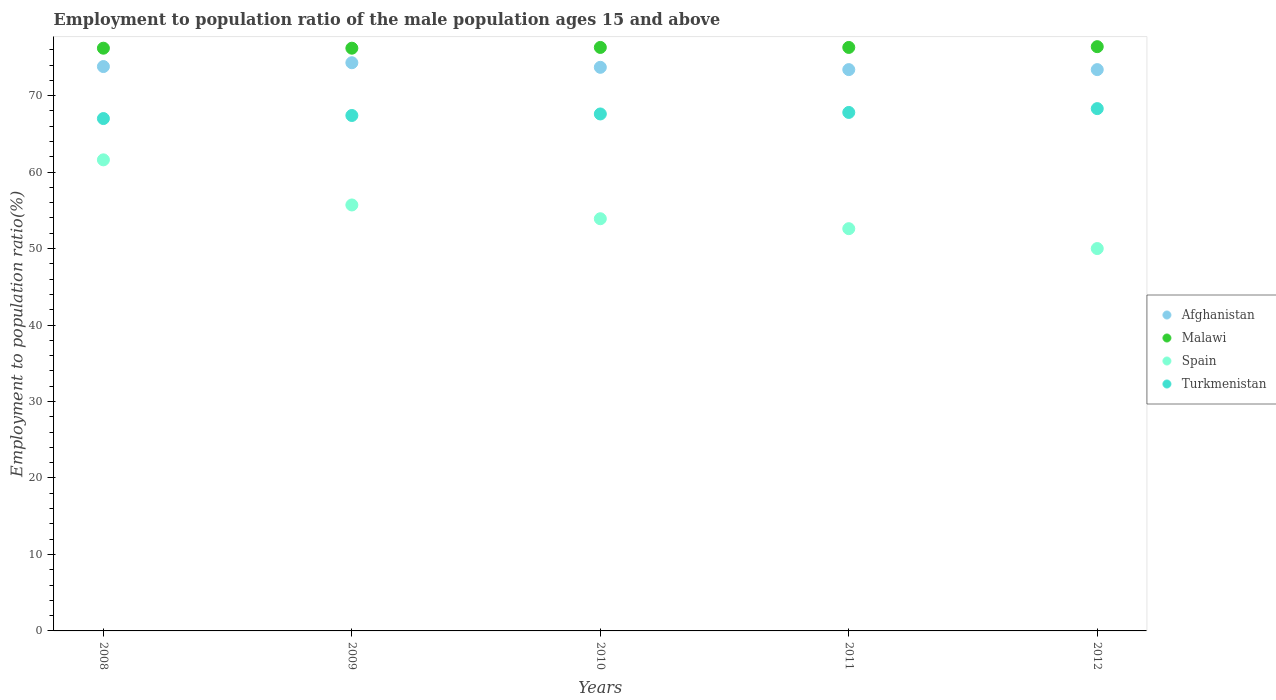What is the employment to population ratio in Spain in 2010?
Your response must be concise. 53.9. Across all years, what is the maximum employment to population ratio in Malawi?
Make the answer very short. 76.4. In which year was the employment to population ratio in Malawi maximum?
Your answer should be compact. 2012. In which year was the employment to population ratio in Spain minimum?
Your answer should be compact. 2012. What is the total employment to population ratio in Spain in the graph?
Ensure brevity in your answer.  273.8. What is the difference between the employment to population ratio in Malawi in 2008 and that in 2011?
Provide a succinct answer. -0.1. What is the difference between the employment to population ratio in Malawi in 2008 and the employment to population ratio in Afghanistan in 2010?
Offer a terse response. 2.5. What is the average employment to population ratio in Afghanistan per year?
Keep it short and to the point. 73.72. In the year 2010, what is the difference between the employment to population ratio in Malawi and employment to population ratio in Afghanistan?
Give a very brief answer. 2.6. What is the ratio of the employment to population ratio in Spain in 2011 to that in 2012?
Provide a short and direct response. 1.05. Is the employment to population ratio in Spain in 2011 less than that in 2012?
Your response must be concise. No. What is the difference between the highest and the second highest employment to population ratio in Malawi?
Give a very brief answer. 0.1. What is the difference between the highest and the lowest employment to population ratio in Malawi?
Your response must be concise. 0.2. Is the sum of the employment to population ratio in Malawi in 2009 and 2011 greater than the maximum employment to population ratio in Afghanistan across all years?
Make the answer very short. Yes. Is it the case that in every year, the sum of the employment to population ratio in Spain and employment to population ratio in Afghanistan  is greater than the employment to population ratio in Turkmenistan?
Provide a succinct answer. Yes. Does the employment to population ratio in Spain monotonically increase over the years?
Ensure brevity in your answer.  No. Is the employment to population ratio in Turkmenistan strictly less than the employment to population ratio in Malawi over the years?
Provide a succinct answer. Yes. Are the values on the major ticks of Y-axis written in scientific E-notation?
Your response must be concise. No. How are the legend labels stacked?
Offer a terse response. Vertical. What is the title of the graph?
Provide a succinct answer. Employment to population ratio of the male population ages 15 and above. Does "Ghana" appear as one of the legend labels in the graph?
Your answer should be compact. No. What is the label or title of the X-axis?
Your answer should be compact. Years. What is the label or title of the Y-axis?
Your response must be concise. Employment to population ratio(%). What is the Employment to population ratio(%) of Afghanistan in 2008?
Provide a succinct answer. 73.8. What is the Employment to population ratio(%) of Malawi in 2008?
Your answer should be compact. 76.2. What is the Employment to population ratio(%) in Spain in 2008?
Provide a succinct answer. 61.6. What is the Employment to population ratio(%) of Turkmenistan in 2008?
Provide a succinct answer. 67. What is the Employment to population ratio(%) of Afghanistan in 2009?
Your answer should be compact. 74.3. What is the Employment to population ratio(%) of Malawi in 2009?
Give a very brief answer. 76.2. What is the Employment to population ratio(%) of Spain in 2009?
Your answer should be very brief. 55.7. What is the Employment to population ratio(%) in Turkmenistan in 2009?
Make the answer very short. 67.4. What is the Employment to population ratio(%) in Afghanistan in 2010?
Make the answer very short. 73.7. What is the Employment to population ratio(%) of Malawi in 2010?
Provide a succinct answer. 76.3. What is the Employment to population ratio(%) of Spain in 2010?
Give a very brief answer. 53.9. What is the Employment to population ratio(%) in Turkmenistan in 2010?
Provide a short and direct response. 67.6. What is the Employment to population ratio(%) in Afghanistan in 2011?
Your response must be concise. 73.4. What is the Employment to population ratio(%) in Malawi in 2011?
Provide a short and direct response. 76.3. What is the Employment to population ratio(%) of Spain in 2011?
Offer a very short reply. 52.6. What is the Employment to population ratio(%) of Turkmenistan in 2011?
Your response must be concise. 67.8. What is the Employment to population ratio(%) in Afghanistan in 2012?
Ensure brevity in your answer.  73.4. What is the Employment to population ratio(%) of Malawi in 2012?
Your response must be concise. 76.4. What is the Employment to population ratio(%) in Turkmenistan in 2012?
Provide a succinct answer. 68.3. Across all years, what is the maximum Employment to population ratio(%) in Afghanistan?
Your answer should be compact. 74.3. Across all years, what is the maximum Employment to population ratio(%) of Malawi?
Offer a very short reply. 76.4. Across all years, what is the maximum Employment to population ratio(%) of Spain?
Ensure brevity in your answer.  61.6. Across all years, what is the maximum Employment to population ratio(%) in Turkmenistan?
Ensure brevity in your answer.  68.3. Across all years, what is the minimum Employment to population ratio(%) in Afghanistan?
Ensure brevity in your answer.  73.4. Across all years, what is the minimum Employment to population ratio(%) in Malawi?
Give a very brief answer. 76.2. What is the total Employment to population ratio(%) of Afghanistan in the graph?
Your answer should be compact. 368.6. What is the total Employment to population ratio(%) of Malawi in the graph?
Your answer should be very brief. 381.4. What is the total Employment to population ratio(%) in Spain in the graph?
Your response must be concise. 273.8. What is the total Employment to population ratio(%) in Turkmenistan in the graph?
Make the answer very short. 338.1. What is the difference between the Employment to population ratio(%) of Afghanistan in 2008 and that in 2009?
Offer a very short reply. -0.5. What is the difference between the Employment to population ratio(%) of Spain in 2008 and that in 2009?
Your answer should be very brief. 5.9. What is the difference between the Employment to population ratio(%) of Turkmenistan in 2008 and that in 2009?
Ensure brevity in your answer.  -0.4. What is the difference between the Employment to population ratio(%) of Afghanistan in 2008 and that in 2011?
Your response must be concise. 0.4. What is the difference between the Employment to population ratio(%) of Malawi in 2008 and that in 2011?
Your answer should be very brief. -0.1. What is the difference between the Employment to population ratio(%) in Turkmenistan in 2008 and that in 2011?
Ensure brevity in your answer.  -0.8. What is the difference between the Employment to population ratio(%) of Afghanistan in 2008 and that in 2012?
Ensure brevity in your answer.  0.4. What is the difference between the Employment to population ratio(%) in Spain in 2008 and that in 2012?
Offer a terse response. 11.6. What is the difference between the Employment to population ratio(%) of Turkmenistan in 2008 and that in 2012?
Provide a short and direct response. -1.3. What is the difference between the Employment to population ratio(%) of Malawi in 2009 and that in 2010?
Make the answer very short. -0.1. What is the difference between the Employment to population ratio(%) in Spain in 2009 and that in 2010?
Your response must be concise. 1.8. What is the difference between the Employment to population ratio(%) in Malawi in 2009 and that in 2011?
Your answer should be compact. -0.1. What is the difference between the Employment to population ratio(%) in Spain in 2009 and that in 2011?
Offer a very short reply. 3.1. What is the difference between the Employment to population ratio(%) of Afghanistan in 2009 and that in 2012?
Make the answer very short. 0.9. What is the difference between the Employment to population ratio(%) in Turkmenistan in 2009 and that in 2012?
Your answer should be compact. -0.9. What is the difference between the Employment to population ratio(%) of Afghanistan in 2010 and that in 2011?
Your answer should be compact. 0.3. What is the difference between the Employment to population ratio(%) of Turkmenistan in 2010 and that in 2011?
Offer a terse response. -0.2. What is the difference between the Employment to population ratio(%) of Malawi in 2010 and that in 2012?
Provide a succinct answer. -0.1. What is the difference between the Employment to population ratio(%) in Turkmenistan in 2010 and that in 2012?
Keep it short and to the point. -0.7. What is the difference between the Employment to population ratio(%) of Afghanistan in 2011 and that in 2012?
Make the answer very short. 0. What is the difference between the Employment to population ratio(%) in Malawi in 2011 and that in 2012?
Provide a succinct answer. -0.1. What is the difference between the Employment to population ratio(%) of Afghanistan in 2008 and the Employment to population ratio(%) of Spain in 2009?
Make the answer very short. 18.1. What is the difference between the Employment to population ratio(%) of Malawi in 2008 and the Employment to population ratio(%) of Turkmenistan in 2009?
Offer a terse response. 8.8. What is the difference between the Employment to population ratio(%) of Spain in 2008 and the Employment to population ratio(%) of Turkmenistan in 2009?
Your response must be concise. -5.8. What is the difference between the Employment to population ratio(%) of Afghanistan in 2008 and the Employment to population ratio(%) of Malawi in 2010?
Offer a terse response. -2.5. What is the difference between the Employment to population ratio(%) of Afghanistan in 2008 and the Employment to population ratio(%) of Spain in 2010?
Your answer should be very brief. 19.9. What is the difference between the Employment to population ratio(%) in Afghanistan in 2008 and the Employment to population ratio(%) in Turkmenistan in 2010?
Provide a succinct answer. 6.2. What is the difference between the Employment to population ratio(%) of Malawi in 2008 and the Employment to population ratio(%) of Spain in 2010?
Ensure brevity in your answer.  22.3. What is the difference between the Employment to population ratio(%) of Malawi in 2008 and the Employment to population ratio(%) of Turkmenistan in 2010?
Provide a succinct answer. 8.6. What is the difference between the Employment to population ratio(%) of Afghanistan in 2008 and the Employment to population ratio(%) of Spain in 2011?
Your answer should be very brief. 21.2. What is the difference between the Employment to population ratio(%) of Malawi in 2008 and the Employment to population ratio(%) of Spain in 2011?
Give a very brief answer. 23.6. What is the difference between the Employment to population ratio(%) in Afghanistan in 2008 and the Employment to population ratio(%) in Spain in 2012?
Provide a short and direct response. 23.8. What is the difference between the Employment to population ratio(%) in Malawi in 2008 and the Employment to population ratio(%) in Spain in 2012?
Offer a very short reply. 26.2. What is the difference between the Employment to population ratio(%) in Malawi in 2008 and the Employment to population ratio(%) in Turkmenistan in 2012?
Offer a terse response. 7.9. What is the difference between the Employment to population ratio(%) of Spain in 2008 and the Employment to population ratio(%) of Turkmenistan in 2012?
Provide a short and direct response. -6.7. What is the difference between the Employment to population ratio(%) of Afghanistan in 2009 and the Employment to population ratio(%) of Spain in 2010?
Your answer should be very brief. 20.4. What is the difference between the Employment to population ratio(%) of Malawi in 2009 and the Employment to population ratio(%) of Spain in 2010?
Offer a terse response. 22.3. What is the difference between the Employment to population ratio(%) in Afghanistan in 2009 and the Employment to population ratio(%) in Malawi in 2011?
Offer a very short reply. -2. What is the difference between the Employment to population ratio(%) in Afghanistan in 2009 and the Employment to population ratio(%) in Spain in 2011?
Offer a very short reply. 21.7. What is the difference between the Employment to population ratio(%) of Malawi in 2009 and the Employment to population ratio(%) of Spain in 2011?
Your response must be concise. 23.6. What is the difference between the Employment to population ratio(%) in Spain in 2009 and the Employment to population ratio(%) in Turkmenistan in 2011?
Your response must be concise. -12.1. What is the difference between the Employment to population ratio(%) in Afghanistan in 2009 and the Employment to population ratio(%) in Spain in 2012?
Ensure brevity in your answer.  24.3. What is the difference between the Employment to population ratio(%) in Afghanistan in 2009 and the Employment to population ratio(%) in Turkmenistan in 2012?
Your answer should be very brief. 6. What is the difference between the Employment to population ratio(%) of Malawi in 2009 and the Employment to population ratio(%) of Spain in 2012?
Make the answer very short. 26.2. What is the difference between the Employment to population ratio(%) of Malawi in 2009 and the Employment to population ratio(%) of Turkmenistan in 2012?
Make the answer very short. 7.9. What is the difference between the Employment to population ratio(%) of Afghanistan in 2010 and the Employment to population ratio(%) of Spain in 2011?
Offer a terse response. 21.1. What is the difference between the Employment to population ratio(%) in Afghanistan in 2010 and the Employment to population ratio(%) in Turkmenistan in 2011?
Ensure brevity in your answer.  5.9. What is the difference between the Employment to population ratio(%) in Malawi in 2010 and the Employment to population ratio(%) in Spain in 2011?
Offer a very short reply. 23.7. What is the difference between the Employment to population ratio(%) in Malawi in 2010 and the Employment to population ratio(%) in Turkmenistan in 2011?
Make the answer very short. 8.5. What is the difference between the Employment to population ratio(%) of Afghanistan in 2010 and the Employment to population ratio(%) of Spain in 2012?
Offer a terse response. 23.7. What is the difference between the Employment to population ratio(%) in Afghanistan in 2010 and the Employment to population ratio(%) in Turkmenistan in 2012?
Offer a very short reply. 5.4. What is the difference between the Employment to population ratio(%) of Malawi in 2010 and the Employment to population ratio(%) of Spain in 2012?
Offer a terse response. 26.3. What is the difference between the Employment to population ratio(%) of Spain in 2010 and the Employment to population ratio(%) of Turkmenistan in 2012?
Your answer should be compact. -14.4. What is the difference between the Employment to population ratio(%) in Afghanistan in 2011 and the Employment to population ratio(%) in Malawi in 2012?
Offer a terse response. -3. What is the difference between the Employment to population ratio(%) of Afghanistan in 2011 and the Employment to population ratio(%) of Spain in 2012?
Offer a very short reply. 23.4. What is the difference between the Employment to population ratio(%) in Afghanistan in 2011 and the Employment to population ratio(%) in Turkmenistan in 2012?
Your answer should be very brief. 5.1. What is the difference between the Employment to population ratio(%) of Malawi in 2011 and the Employment to population ratio(%) of Spain in 2012?
Offer a very short reply. 26.3. What is the difference between the Employment to population ratio(%) of Spain in 2011 and the Employment to population ratio(%) of Turkmenistan in 2012?
Make the answer very short. -15.7. What is the average Employment to population ratio(%) of Afghanistan per year?
Ensure brevity in your answer.  73.72. What is the average Employment to population ratio(%) of Malawi per year?
Keep it short and to the point. 76.28. What is the average Employment to population ratio(%) of Spain per year?
Your answer should be compact. 54.76. What is the average Employment to population ratio(%) in Turkmenistan per year?
Give a very brief answer. 67.62. In the year 2008, what is the difference between the Employment to population ratio(%) in Afghanistan and Employment to population ratio(%) in Spain?
Give a very brief answer. 12.2. In the year 2008, what is the difference between the Employment to population ratio(%) of Malawi and Employment to population ratio(%) of Turkmenistan?
Give a very brief answer. 9.2. In the year 2009, what is the difference between the Employment to population ratio(%) of Afghanistan and Employment to population ratio(%) of Malawi?
Provide a short and direct response. -1.9. In the year 2009, what is the difference between the Employment to population ratio(%) in Afghanistan and Employment to population ratio(%) in Turkmenistan?
Provide a succinct answer. 6.9. In the year 2009, what is the difference between the Employment to population ratio(%) of Malawi and Employment to population ratio(%) of Spain?
Offer a terse response. 20.5. In the year 2009, what is the difference between the Employment to population ratio(%) of Malawi and Employment to population ratio(%) of Turkmenistan?
Provide a short and direct response. 8.8. In the year 2009, what is the difference between the Employment to population ratio(%) in Spain and Employment to population ratio(%) in Turkmenistan?
Give a very brief answer. -11.7. In the year 2010, what is the difference between the Employment to population ratio(%) in Afghanistan and Employment to population ratio(%) in Spain?
Keep it short and to the point. 19.8. In the year 2010, what is the difference between the Employment to population ratio(%) of Afghanistan and Employment to population ratio(%) of Turkmenistan?
Your answer should be compact. 6.1. In the year 2010, what is the difference between the Employment to population ratio(%) of Malawi and Employment to population ratio(%) of Spain?
Your answer should be compact. 22.4. In the year 2010, what is the difference between the Employment to population ratio(%) of Spain and Employment to population ratio(%) of Turkmenistan?
Keep it short and to the point. -13.7. In the year 2011, what is the difference between the Employment to population ratio(%) of Afghanistan and Employment to population ratio(%) of Malawi?
Provide a succinct answer. -2.9. In the year 2011, what is the difference between the Employment to population ratio(%) of Afghanistan and Employment to population ratio(%) of Spain?
Your response must be concise. 20.8. In the year 2011, what is the difference between the Employment to population ratio(%) of Afghanistan and Employment to population ratio(%) of Turkmenistan?
Offer a very short reply. 5.6. In the year 2011, what is the difference between the Employment to population ratio(%) in Malawi and Employment to population ratio(%) in Spain?
Your answer should be very brief. 23.7. In the year 2011, what is the difference between the Employment to population ratio(%) of Malawi and Employment to population ratio(%) of Turkmenistan?
Provide a succinct answer. 8.5. In the year 2011, what is the difference between the Employment to population ratio(%) in Spain and Employment to population ratio(%) in Turkmenistan?
Ensure brevity in your answer.  -15.2. In the year 2012, what is the difference between the Employment to population ratio(%) of Afghanistan and Employment to population ratio(%) of Malawi?
Offer a terse response. -3. In the year 2012, what is the difference between the Employment to population ratio(%) in Afghanistan and Employment to population ratio(%) in Spain?
Make the answer very short. 23.4. In the year 2012, what is the difference between the Employment to population ratio(%) of Malawi and Employment to population ratio(%) of Spain?
Offer a terse response. 26.4. In the year 2012, what is the difference between the Employment to population ratio(%) in Spain and Employment to population ratio(%) in Turkmenistan?
Keep it short and to the point. -18.3. What is the ratio of the Employment to population ratio(%) in Malawi in 2008 to that in 2009?
Ensure brevity in your answer.  1. What is the ratio of the Employment to population ratio(%) in Spain in 2008 to that in 2009?
Provide a succinct answer. 1.11. What is the ratio of the Employment to population ratio(%) in Turkmenistan in 2008 to that in 2009?
Make the answer very short. 0.99. What is the ratio of the Employment to population ratio(%) of Afghanistan in 2008 to that in 2010?
Keep it short and to the point. 1. What is the ratio of the Employment to population ratio(%) of Malawi in 2008 to that in 2010?
Offer a very short reply. 1. What is the ratio of the Employment to population ratio(%) of Spain in 2008 to that in 2010?
Provide a short and direct response. 1.14. What is the ratio of the Employment to population ratio(%) of Turkmenistan in 2008 to that in 2010?
Give a very brief answer. 0.99. What is the ratio of the Employment to population ratio(%) of Afghanistan in 2008 to that in 2011?
Ensure brevity in your answer.  1.01. What is the ratio of the Employment to population ratio(%) of Spain in 2008 to that in 2011?
Your answer should be compact. 1.17. What is the ratio of the Employment to population ratio(%) in Afghanistan in 2008 to that in 2012?
Offer a very short reply. 1.01. What is the ratio of the Employment to population ratio(%) of Malawi in 2008 to that in 2012?
Provide a succinct answer. 1. What is the ratio of the Employment to population ratio(%) in Spain in 2008 to that in 2012?
Your answer should be very brief. 1.23. What is the ratio of the Employment to population ratio(%) of Spain in 2009 to that in 2010?
Your response must be concise. 1.03. What is the ratio of the Employment to population ratio(%) of Afghanistan in 2009 to that in 2011?
Your answer should be compact. 1.01. What is the ratio of the Employment to population ratio(%) of Malawi in 2009 to that in 2011?
Your response must be concise. 1. What is the ratio of the Employment to population ratio(%) of Spain in 2009 to that in 2011?
Provide a succinct answer. 1.06. What is the ratio of the Employment to population ratio(%) of Turkmenistan in 2009 to that in 2011?
Give a very brief answer. 0.99. What is the ratio of the Employment to population ratio(%) of Afghanistan in 2009 to that in 2012?
Ensure brevity in your answer.  1.01. What is the ratio of the Employment to population ratio(%) in Spain in 2009 to that in 2012?
Give a very brief answer. 1.11. What is the ratio of the Employment to population ratio(%) in Turkmenistan in 2009 to that in 2012?
Ensure brevity in your answer.  0.99. What is the ratio of the Employment to population ratio(%) in Afghanistan in 2010 to that in 2011?
Your response must be concise. 1. What is the ratio of the Employment to population ratio(%) of Malawi in 2010 to that in 2011?
Offer a terse response. 1. What is the ratio of the Employment to population ratio(%) of Spain in 2010 to that in 2011?
Your answer should be very brief. 1.02. What is the ratio of the Employment to population ratio(%) of Afghanistan in 2010 to that in 2012?
Your response must be concise. 1. What is the ratio of the Employment to population ratio(%) of Malawi in 2010 to that in 2012?
Keep it short and to the point. 1. What is the ratio of the Employment to population ratio(%) of Spain in 2010 to that in 2012?
Your response must be concise. 1.08. What is the ratio of the Employment to population ratio(%) in Turkmenistan in 2010 to that in 2012?
Your answer should be compact. 0.99. What is the ratio of the Employment to population ratio(%) in Afghanistan in 2011 to that in 2012?
Your answer should be very brief. 1. What is the ratio of the Employment to population ratio(%) in Spain in 2011 to that in 2012?
Your answer should be compact. 1.05. What is the ratio of the Employment to population ratio(%) of Turkmenistan in 2011 to that in 2012?
Provide a succinct answer. 0.99. What is the difference between the highest and the second highest Employment to population ratio(%) in Afghanistan?
Offer a terse response. 0.5. What is the difference between the highest and the second highest Employment to population ratio(%) of Spain?
Your answer should be very brief. 5.9. What is the difference between the highest and the second highest Employment to population ratio(%) of Turkmenistan?
Your answer should be very brief. 0.5. What is the difference between the highest and the lowest Employment to population ratio(%) of Spain?
Offer a terse response. 11.6. What is the difference between the highest and the lowest Employment to population ratio(%) in Turkmenistan?
Offer a very short reply. 1.3. 